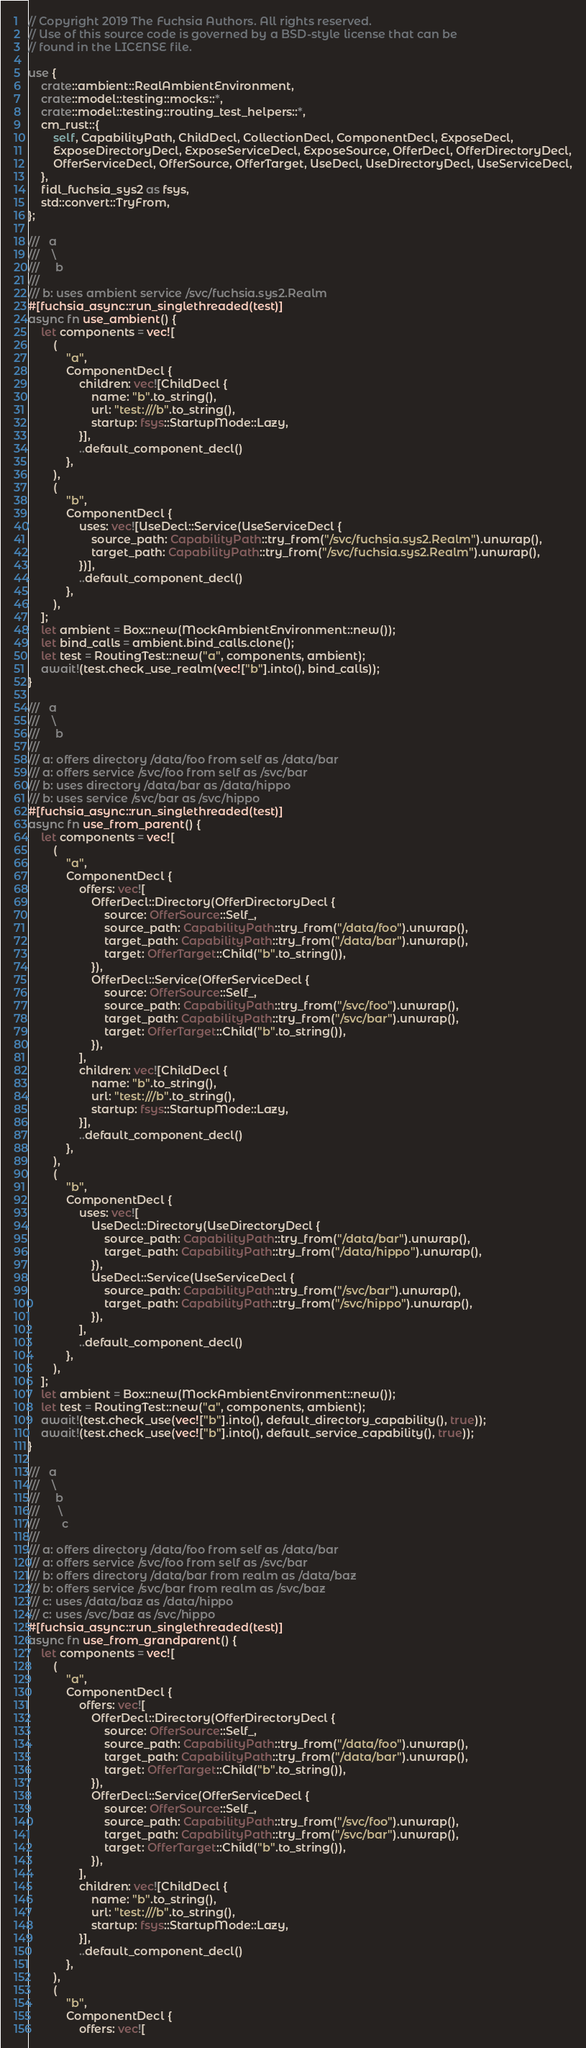Convert code to text. <code><loc_0><loc_0><loc_500><loc_500><_Rust_>// Copyright 2019 The Fuchsia Authors. All rights reserved.
// Use of this source code is governed by a BSD-style license that can be
// found in the LICENSE file.

use {
    crate::ambient::RealAmbientEnvironment,
    crate::model::testing::mocks::*,
    crate::model::testing::routing_test_helpers::*,
    cm_rust::{
        self, CapabilityPath, ChildDecl, CollectionDecl, ComponentDecl, ExposeDecl,
        ExposeDirectoryDecl, ExposeServiceDecl, ExposeSource, OfferDecl, OfferDirectoryDecl,
        OfferServiceDecl, OfferSource, OfferTarget, UseDecl, UseDirectoryDecl, UseServiceDecl,
    },
    fidl_fuchsia_sys2 as fsys,
    std::convert::TryFrom,
};

///   a
///    \
///     b
///
/// b: uses ambient service /svc/fuchsia.sys2.Realm
#[fuchsia_async::run_singlethreaded(test)]
async fn use_ambient() {
    let components = vec![
        (
            "a",
            ComponentDecl {
                children: vec![ChildDecl {
                    name: "b".to_string(),
                    url: "test:///b".to_string(),
                    startup: fsys::StartupMode::Lazy,
                }],
                ..default_component_decl()
            },
        ),
        (
            "b",
            ComponentDecl {
                uses: vec![UseDecl::Service(UseServiceDecl {
                    source_path: CapabilityPath::try_from("/svc/fuchsia.sys2.Realm").unwrap(),
                    target_path: CapabilityPath::try_from("/svc/fuchsia.sys2.Realm").unwrap(),
                })],
                ..default_component_decl()
            },
        ),
    ];
    let ambient = Box::new(MockAmbientEnvironment::new());
    let bind_calls = ambient.bind_calls.clone();
    let test = RoutingTest::new("a", components, ambient);
    await!(test.check_use_realm(vec!["b"].into(), bind_calls));
}

///   a
///    \
///     b
///
/// a: offers directory /data/foo from self as /data/bar
/// a: offers service /svc/foo from self as /svc/bar
/// b: uses directory /data/bar as /data/hippo
/// b: uses service /svc/bar as /svc/hippo
#[fuchsia_async::run_singlethreaded(test)]
async fn use_from_parent() {
    let components = vec![
        (
            "a",
            ComponentDecl {
                offers: vec![
                    OfferDecl::Directory(OfferDirectoryDecl {
                        source: OfferSource::Self_,
                        source_path: CapabilityPath::try_from("/data/foo").unwrap(),
                        target_path: CapabilityPath::try_from("/data/bar").unwrap(),
                        target: OfferTarget::Child("b".to_string()),
                    }),
                    OfferDecl::Service(OfferServiceDecl {
                        source: OfferSource::Self_,
                        source_path: CapabilityPath::try_from("/svc/foo").unwrap(),
                        target_path: CapabilityPath::try_from("/svc/bar").unwrap(),
                        target: OfferTarget::Child("b".to_string()),
                    }),
                ],
                children: vec![ChildDecl {
                    name: "b".to_string(),
                    url: "test:///b".to_string(),
                    startup: fsys::StartupMode::Lazy,
                }],
                ..default_component_decl()
            },
        ),
        (
            "b",
            ComponentDecl {
                uses: vec![
                    UseDecl::Directory(UseDirectoryDecl {
                        source_path: CapabilityPath::try_from("/data/bar").unwrap(),
                        target_path: CapabilityPath::try_from("/data/hippo").unwrap(),
                    }),
                    UseDecl::Service(UseServiceDecl {
                        source_path: CapabilityPath::try_from("/svc/bar").unwrap(),
                        target_path: CapabilityPath::try_from("/svc/hippo").unwrap(),
                    }),
                ],
                ..default_component_decl()
            },
        ),
    ];
    let ambient = Box::new(MockAmbientEnvironment::new());
    let test = RoutingTest::new("a", components, ambient);
    await!(test.check_use(vec!["b"].into(), default_directory_capability(), true));
    await!(test.check_use(vec!["b"].into(), default_service_capability(), true));
}

///   a
///    \
///     b
///      \
///       c
///
/// a: offers directory /data/foo from self as /data/bar
/// a: offers service /svc/foo from self as /svc/bar
/// b: offers directory /data/bar from realm as /data/baz
/// b: offers service /svc/bar from realm as /svc/baz
/// c: uses /data/baz as /data/hippo
/// c: uses /svc/baz as /svc/hippo
#[fuchsia_async::run_singlethreaded(test)]
async fn use_from_grandparent() {
    let components = vec![
        (
            "a",
            ComponentDecl {
                offers: vec![
                    OfferDecl::Directory(OfferDirectoryDecl {
                        source: OfferSource::Self_,
                        source_path: CapabilityPath::try_from("/data/foo").unwrap(),
                        target_path: CapabilityPath::try_from("/data/bar").unwrap(),
                        target: OfferTarget::Child("b".to_string()),
                    }),
                    OfferDecl::Service(OfferServiceDecl {
                        source: OfferSource::Self_,
                        source_path: CapabilityPath::try_from("/svc/foo").unwrap(),
                        target_path: CapabilityPath::try_from("/svc/bar").unwrap(),
                        target: OfferTarget::Child("b".to_string()),
                    }),
                ],
                children: vec![ChildDecl {
                    name: "b".to_string(),
                    url: "test:///b".to_string(),
                    startup: fsys::StartupMode::Lazy,
                }],
                ..default_component_decl()
            },
        ),
        (
            "b",
            ComponentDecl {
                offers: vec![</code> 